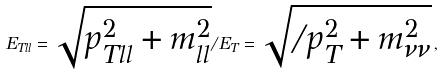Convert formula to latex. <formula><loc_0><loc_0><loc_500><loc_500>E _ { T l l } = \sqrt { p _ { T l l } ^ { 2 } + m ^ { 2 } _ { l l } } \slash E _ { T } = \sqrt { \slash p _ { T } ^ { 2 } + m ^ { 2 } _ { \nu \nu } } \, ,</formula> 